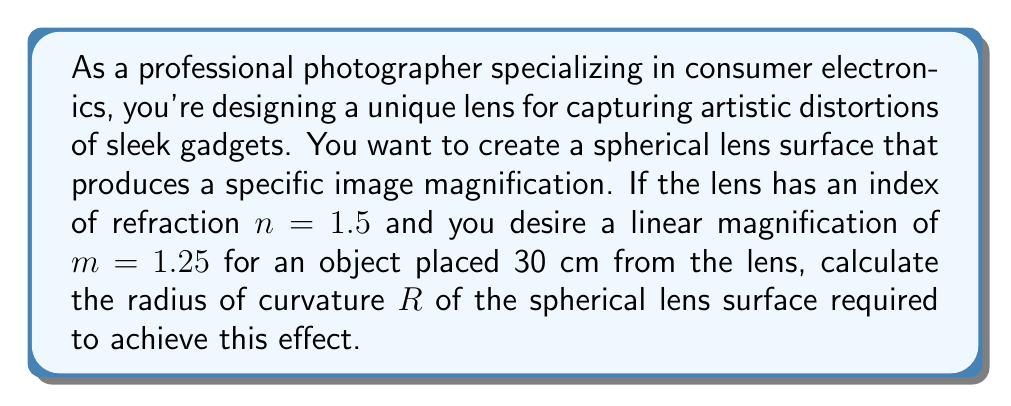Solve this math problem. To solve this problem, we'll use concepts from non-Euclidean geometry and optics. Let's approach this step-by-step:

1) First, recall the thin lens equation:

   $$\frac{1}{f} = \frac{1}{s_o} + \frac{1}{s_i}$$

   where $f$ is the focal length, $s_o$ is the object distance, and $s_i$ is the image distance.

2) We know the object distance $s_o = 30$ cm. We can find $s_i$ using the magnification formula:

   $$m = -\frac{s_i}{s_o}$$

   $$1.25 = -\frac{s_i}{30}$$
   $$s_i = -37.5 \text{ cm}$$

3) Now we can calculate the focal length:

   $$\frac{1}{f} = \frac{1}{30} + \frac{1}{-37.5}$$
   $$\frac{1}{f} = \frac{1}{30} - \frac{1}{37.5} = -\frac{1}{150}$$
   $$f = -150 \text{ cm}$$

4) For a spherical surface, the radius of curvature $R$ is related to the focal length by the lens maker's equation:

   $$\frac{1}{f} = \frac{n-1}{R}$$

   where $n$ is the index of refraction.

5) Substituting our known values:

   $$-\frac{1}{150} = \frac{1.5-1}{R}$$
   $$-\frac{1}{150} = \frac{0.5}{R}$$

6) Solving for $R$:

   $$R = -0.5 \cdot 150 = -75 \text{ cm}$$

The negative sign indicates that the center of curvature is on the same side as the incident light, meaning the lens surface is convex.
Answer: $R = -75 \text{ cm}$ 